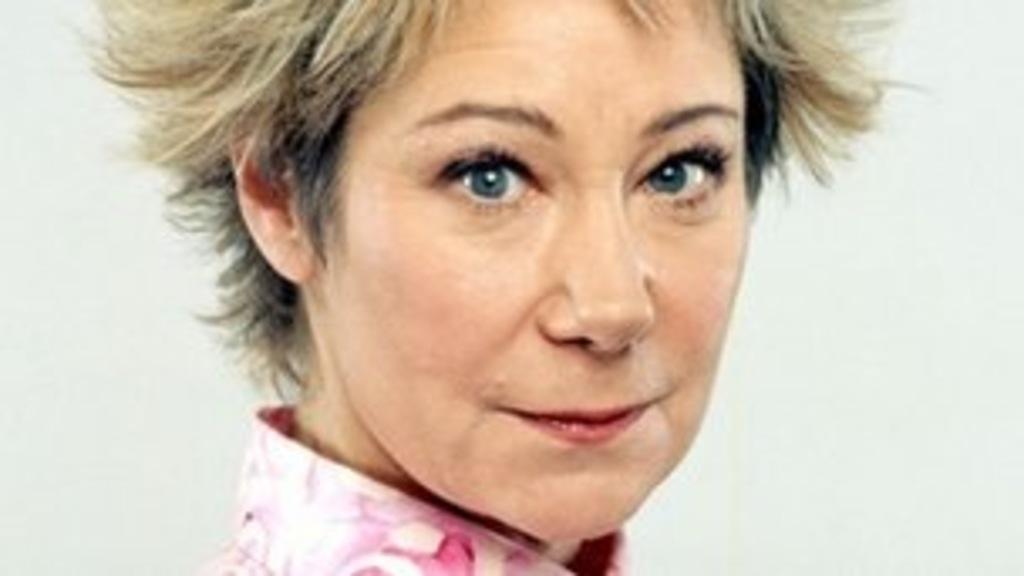Please provide a concise description of this image. In this picture I can see a person, and there is white background. 